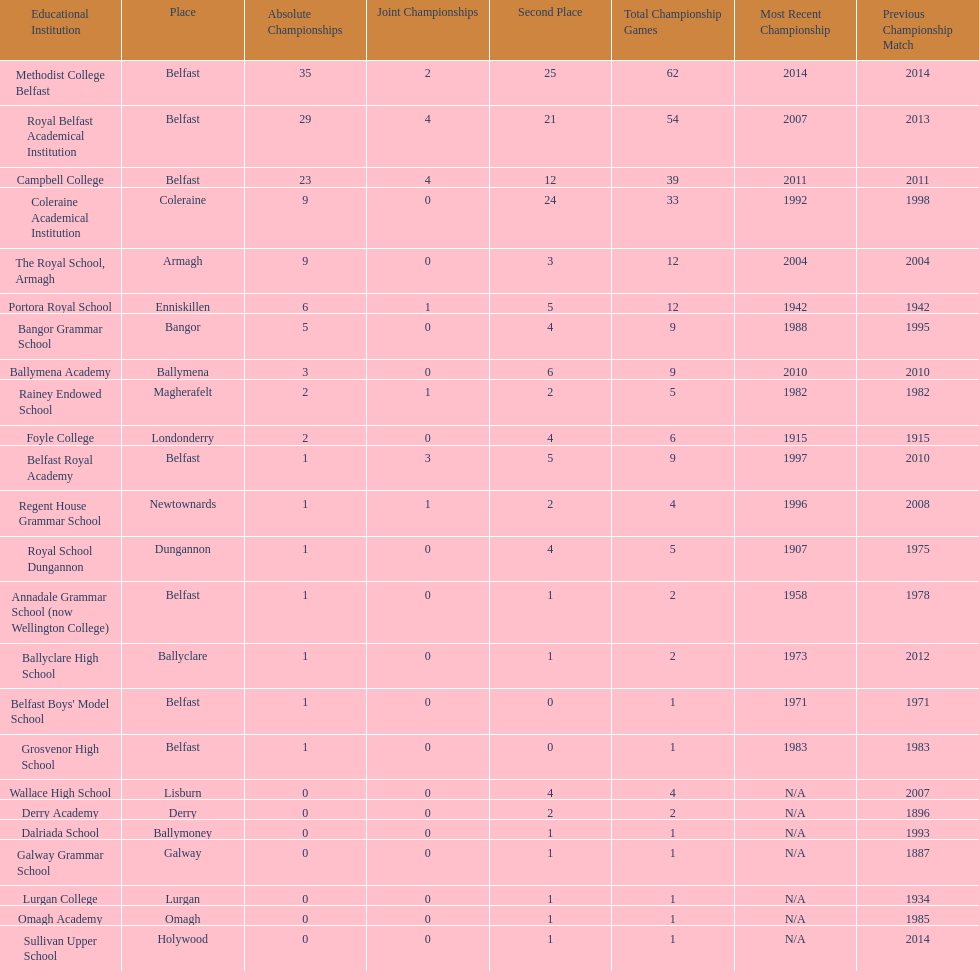How many schools had above 5 outright titles? 6. Can you give me this table as a dict? {'header': ['Educational Institution', 'Place', 'Absolute Championships', 'Joint Championships', 'Second Place', 'Total Championship Games', 'Most Recent Championship', 'Previous Championship Match'], 'rows': [['Methodist College Belfast', 'Belfast', '35', '2', '25', '62', '2014', '2014'], ['Royal Belfast Academical Institution', 'Belfast', '29', '4', '21', '54', '2007', '2013'], ['Campbell College', 'Belfast', '23', '4', '12', '39', '2011', '2011'], ['Coleraine Academical Institution', 'Coleraine', '9', '0', '24', '33', '1992', '1998'], ['The Royal School, Armagh', 'Armagh', '9', '0', '3', '12', '2004', '2004'], ['Portora Royal School', 'Enniskillen', '6', '1', '5', '12', '1942', '1942'], ['Bangor Grammar School', 'Bangor', '5', '0', '4', '9', '1988', '1995'], ['Ballymena Academy', 'Ballymena', '3', '0', '6', '9', '2010', '2010'], ['Rainey Endowed School', 'Magherafelt', '2', '1', '2', '5', '1982', '1982'], ['Foyle College', 'Londonderry', '2', '0', '4', '6', '1915', '1915'], ['Belfast Royal Academy', 'Belfast', '1', '3', '5', '9', '1997', '2010'], ['Regent House Grammar School', 'Newtownards', '1', '1', '2', '4', '1996', '2008'], ['Royal School Dungannon', 'Dungannon', '1', '0', '4', '5', '1907', '1975'], ['Annadale Grammar School (now Wellington College)', 'Belfast', '1', '0', '1', '2', '1958', '1978'], ['Ballyclare High School', 'Ballyclare', '1', '0', '1', '2', '1973', '2012'], ["Belfast Boys' Model School", 'Belfast', '1', '0', '0', '1', '1971', '1971'], ['Grosvenor High School', 'Belfast', '1', '0', '0', '1', '1983', '1983'], ['Wallace High School', 'Lisburn', '0', '0', '4', '4', 'N/A', '2007'], ['Derry Academy', 'Derry', '0', '0', '2', '2', 'N/A', '1896'], ['Dalriada School', 'Ballymoney', '0', '0', '1', '1', 'N/A', '1993'], ['Galway Grammar School', 'Galway', '0', '0', '1', '1', 'N/A', '1887'], ['Lurgan College', 'Lurgan', '0', '0', '1', '1', 'N/A', '1934'], ['Omagh Academy', 'Omagh', '0', '0', '1', '1', 'N/A', '1985'], ['Sullivan Upper School', 'Holywood', '0', '0', '1', '1', 'N/A', '2014']]} 